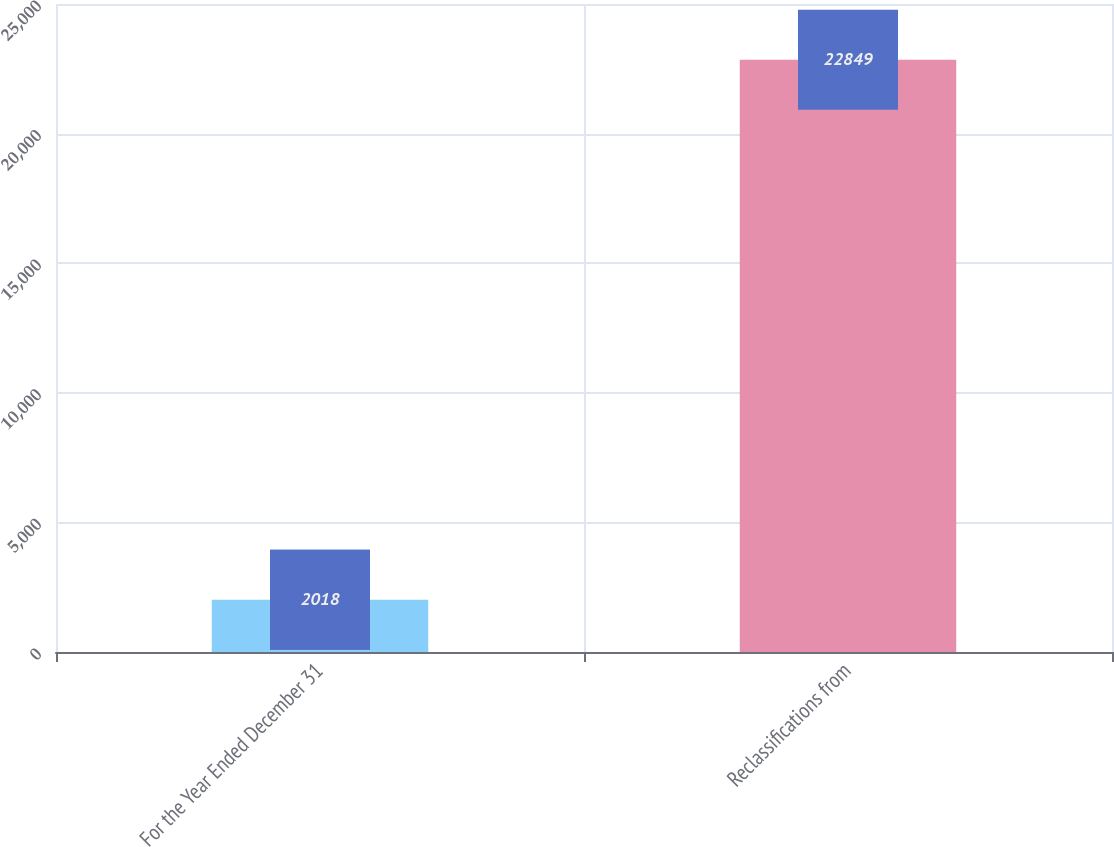Convert chart. <chart><loc_0><loc_0><loc_500><loc_500><bar_chart><fcel>For the Year Ended December 31<fcel>Reclassifications from<nl><fcel>2018<fcel>22849<nl></chart> 